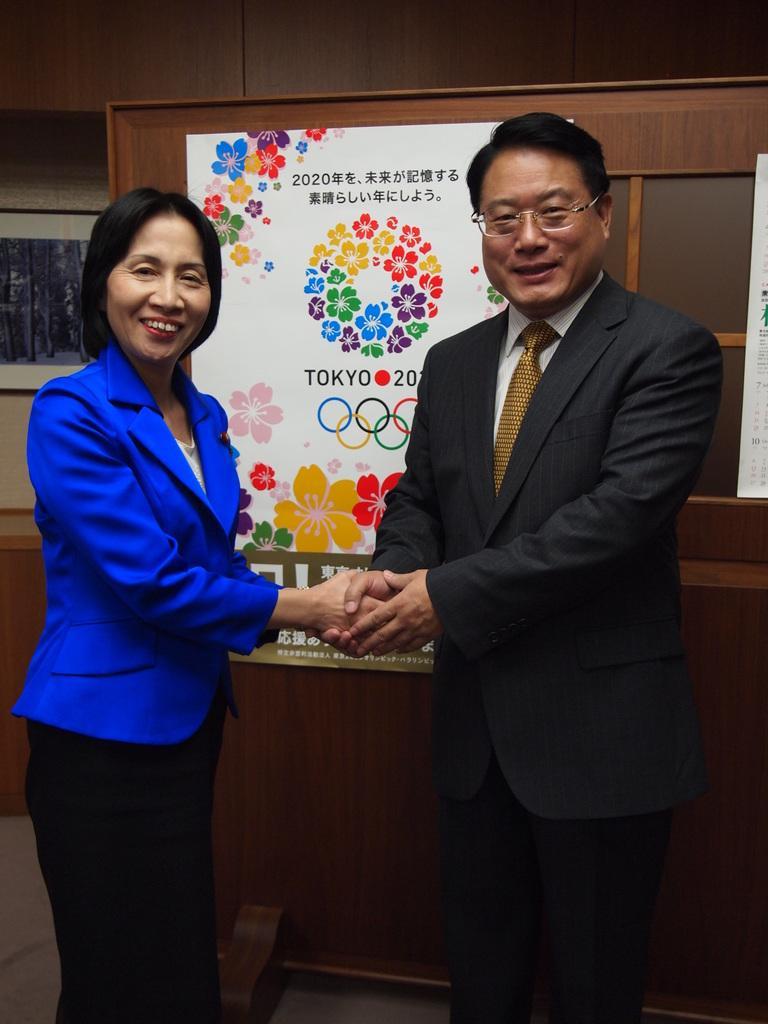Describe this image in one or two sentences. In this picture I can observe a man and woman. Both of them are wearing coats. They are smiling. Behind them I can observe a poster. 